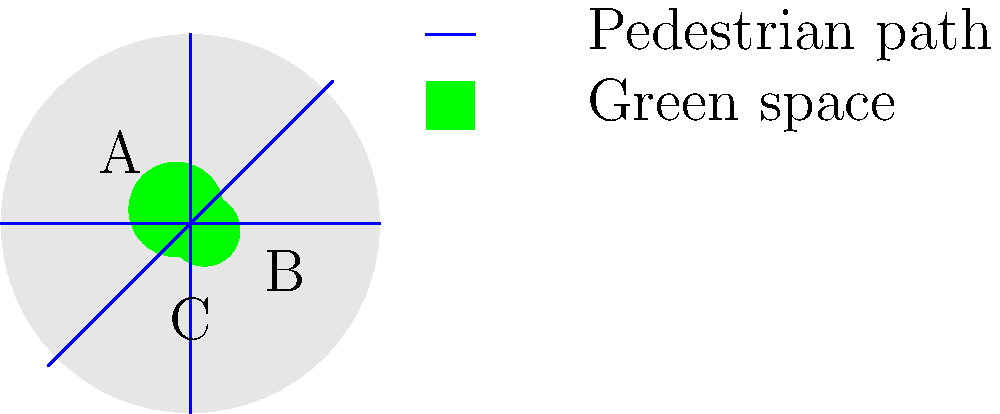In the reimagined urban area shown above, which green space has the highest level of pedestrian connectivity, and what percentage of the total green area does it represent? To answer this question, we need to follow these steps:

1. Identify the green spaces: There are three green spaces labeled A, B, and C.

2. Analyze pedestrian connectivity:
   - Space A: Connected to 3 pedestrian paths
   - Space B: Connected to 1 pedestrian path
   - Space C: Connected to 2 pedestrian paths

   Space A has the highest level of pedestrian connectivity.

3. Calculate the areas of the green spaces:
   Let $r$ be the radius of the urban area (circle).
   - Area of A: $\pi(0.25r)^2 = 0.0625\pi r^2$
   - Area of B: $\pi(0.1875r)^2 \approx 0.0352\pi r^2$
   - Area of C: $\pi(0.125r)^2 = 0.0156\pi r^2$

4. Calculate the total green area:
   Total area = $0.0625\pi r^2 + 0.0352\pi r^2 + 0.0156\pi r^2 = 0.1133\pi r^2$

5. Calculate the percentage of space A:
   Percentage = $\frac{0.0625\pi r^2}{0.1133\pi r^2} \times 100\% \approx 55.16\%$

Therefore, green space A has the highest level of pedestrian connectivity and represents approximately 55.16% of the total green area.
Answer: Space A, 55.16% 